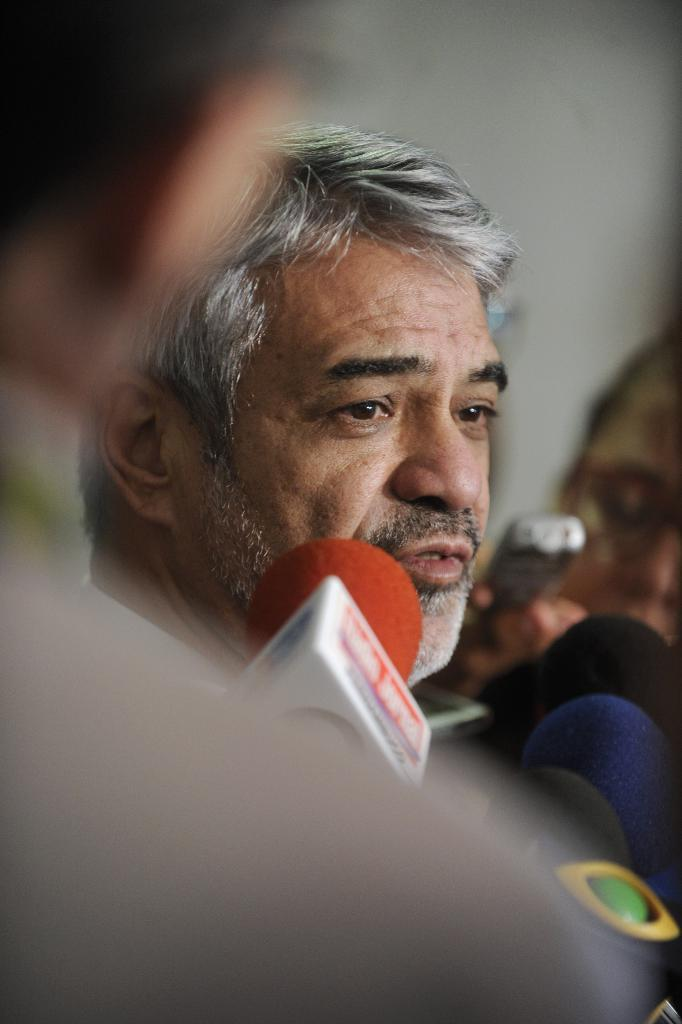What are the persons in the image holding? The persons in the image are holding microphones. What might the persons holding microphones be doing? They might be performing or giving a speech. Can you describe the man standing and watching behind them? The man is standing and watching the persons holding microphones. How many snails can be seen crawling on the microphones in the image? There are no snails present in the image; the persons are holding microphones. What type of lock is securing the yak in the image? There is no yak or lock present in the image. 